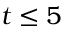<formula> <loc_0><loc_0><loc_500><loc_500>t \leq 5</formula> 